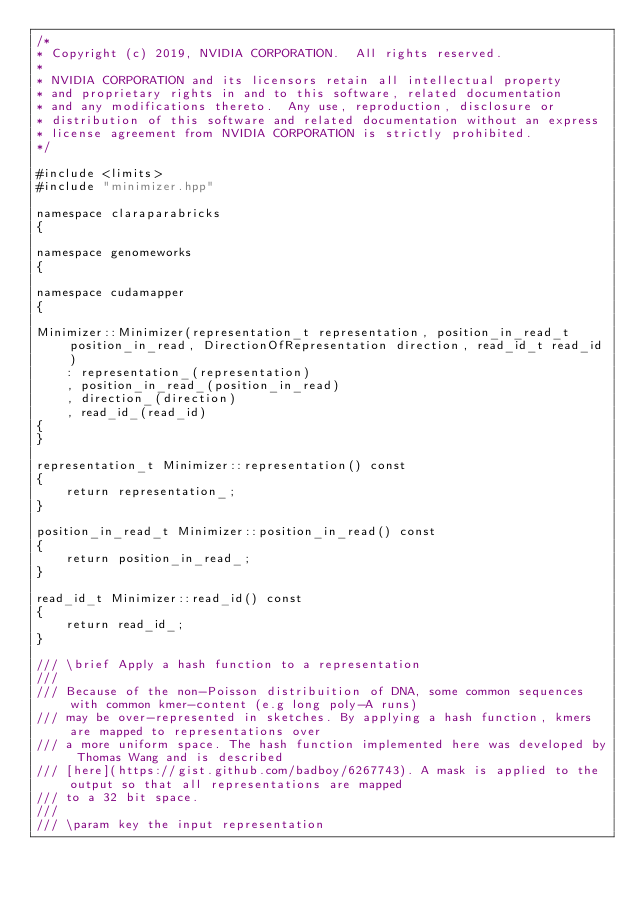Convert code to text. <code><loc_0><loc_0><loc_500><loc_500><_Cuda_>/*
* Copyright (c) 2019, NVIDIA CORPORATION.  All rights reserved.
*
* NVIDIA CORPORATION and its licensors retain all intellectual property
* and proprietary rights in and to this software, related documentation
* and any modifications thereto.  Any use, reproduction, disclosure or
* distribution of this software and related documentation without an express
* license agreement from NVIDIA CORPORATION is strictly prohibited.
*/

#include <limits>
#include "minimizer.hpp"

namespace claraparabricks
{

namespace genomeworks
{

namespace cudamapper
{

Minimizer::Minimizer(representation_t representation, position_in_read_t position_in_read, DirectionOfRepresentation direction, read_id_t read_id)
    : representation_(representation)
    , position_in_read_(position_in_read)
    , direction_(direction)
    , read_id_(read_id)
{
}

representation_t Minimizer::representation() const
{
    return representation_;
}

position_in_read_t Minimizer::position_in_read() const
{
    return position_in_read_;
}

read_id_t Minimizer::read_id() const
{
    return read_id_;
}

/// \brief Apply a hash function to a representation
///
/// Because of the non-Poisson distribuition of DNA, some common sequences with common kmer-content (e.g long poly-A runs)
/// may be over-represented in sketches. By applying a hash function, kmers are mapped to representations over
/// a more uniform space. The hash function implemented here was developed by Thomas Wang and is described
/// [here](https://gist.github.com/badboy/6267743). A mask is applied to the output so that all representations are mapped
/// to a 32 bit space.
///
/// \param key the input representation</code> 